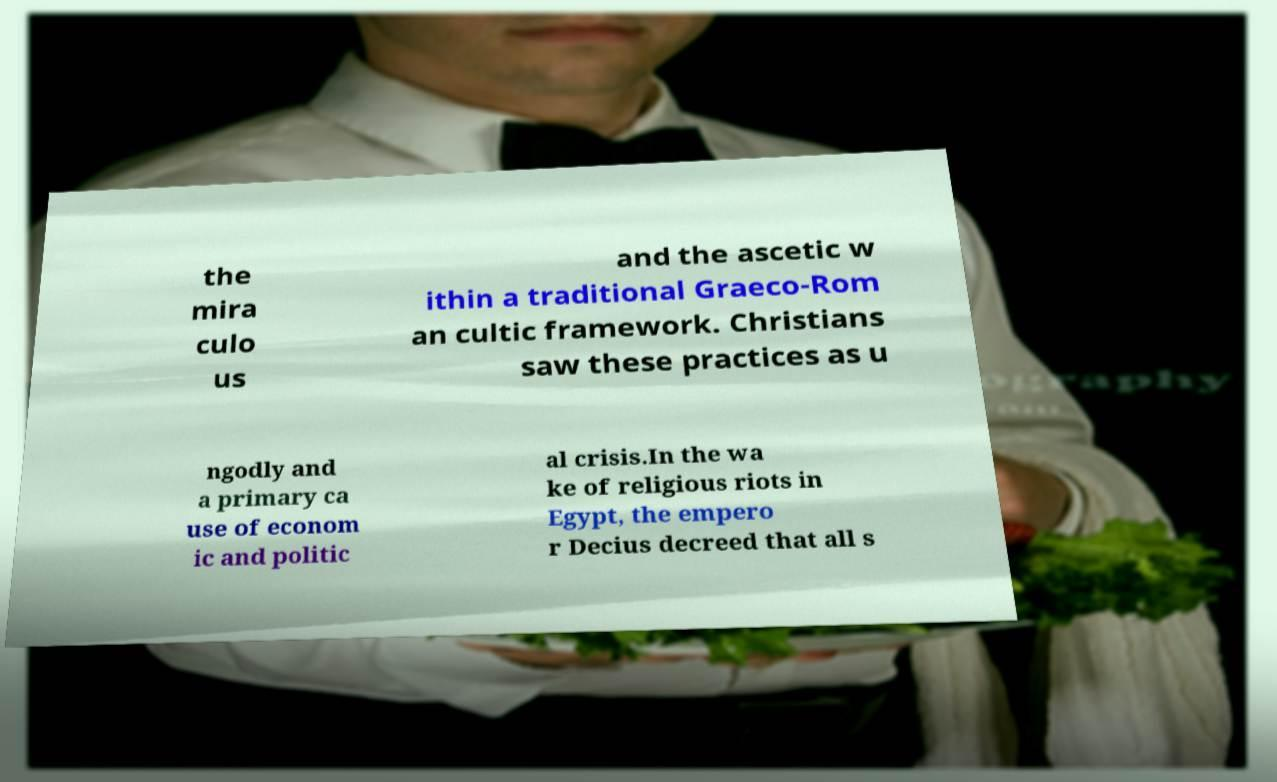Please identify and transcribe the text found in this image. the mira culo us and the ascetic w ithin a traditional Graeco-Rom an cultic framework. Christians saw these practices as u ngodly and a primary ca use of econom ic and politic al crisis.In the wa ke of religious riots in Egypt, the empero r Decius decreed that all s 